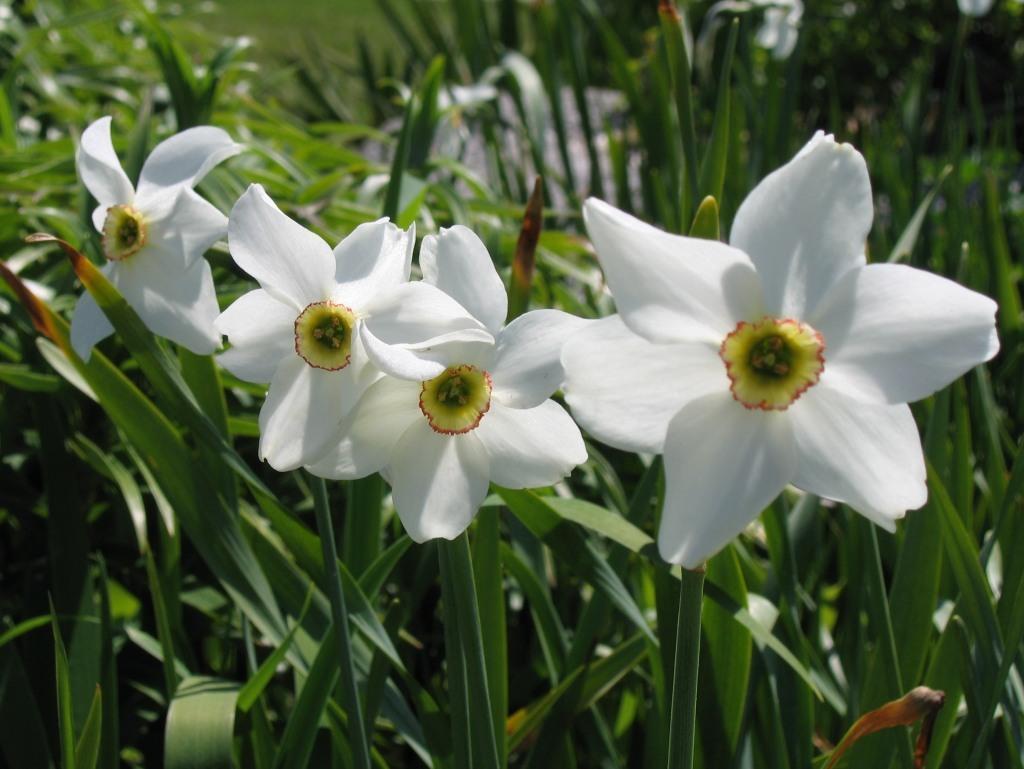Please provide a concise description of this image. This picture shows few plants with flowers and the flowers are white and yellow in color. 